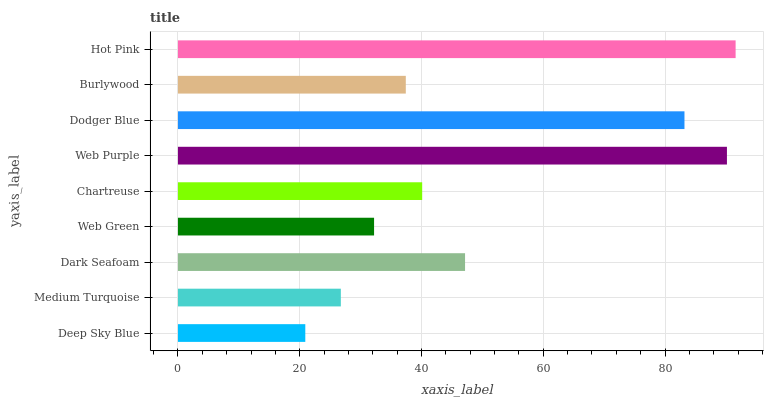Is Deep Sky Blue the minimum?
Answer yes or no. Yes. Is Hot Pink the maximum?
Answer yes or no. Yes. Is Medium Turquoise the minimum?
Answer yes or no. No. Is Medium Turquoise the maximum?
Answer yes or no. No. Is Medium Turquoise greater than Deep Sky Blue?
Answer yes or no. Yes. Is Deep Sky Blue less than Medium Turquoise?
Answer yes or no. Yes. Is Deep Sky Blue greater than Medium Turquoise?
Answer yes or no. No. Is Medium Turquoise less than Deep Sky Blue?
Answer yes or no. No. Is Chartreuse the high median?
Answer yes or no. Yes. Is Chartreuse the low median?
Answer yes or no. Yes. Is Dark Seafoam the high median?
Answer yes or no. No. Is Dark Seafoam the low median?
Answer yes or no. No. 